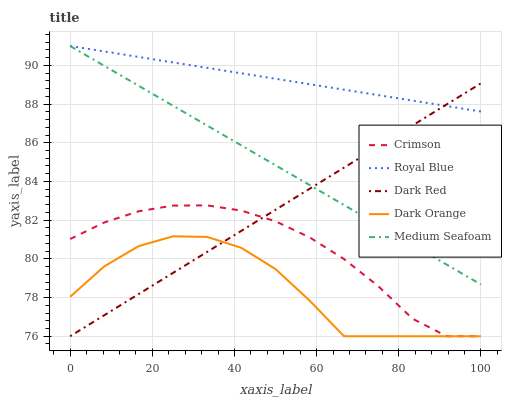Does Dark Orange have the minimum area under the curve?
Answer yes or no. Yes. Does Royal Blue have the maximum area under the curve?
Answer yes or no. Yes. Does Medium Seafoam have the minimum area under the curve?
Answer yes or no. No. Does Medium Seafoam have the maximum area under the curve?
Answer yes or no. No. Is Dark Red the smoothest?
Answer yes or no. Yes. Is Dark Orange the roughest?
Answer yes or no. Yes. Is Royal Blue the smoothest?
Answer yes or no. No. Is Royal Blue the roughest?
Answer yes or no. No. Does Crimson have the lowest value?
Answer yes or no. Yes. Does Medium Seafoam have the lowest value?
Answer yes or no. No. Does Medium Seafoam have the highest value?
Answer yes or no. Yes. Does Dark Orange have the highest value?
Answer yes or no. No. Is Crimson less than Medium Seafoam?
Answer yes or no. Yes. Is Medium Seafoam greater than Dark Orange?
Answer yes or no. Yes. Does Crimson intersect Dark Orange?
Answer yes or no. Yes. Is Crimson less than Dark Orange?
Answer yes or no. No. Is Crimson greater than Dark Orange?
Answer yes or no. No. Does Crimson intersect Medium Seafoam?
Answer yes or no. No. 